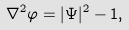<formula> <loc_0><loc_0><loc_500><loc_500>\nabla ^ { 2 } \varphi = | \Psi | ^ { 2 } - 1 ,</formula> 